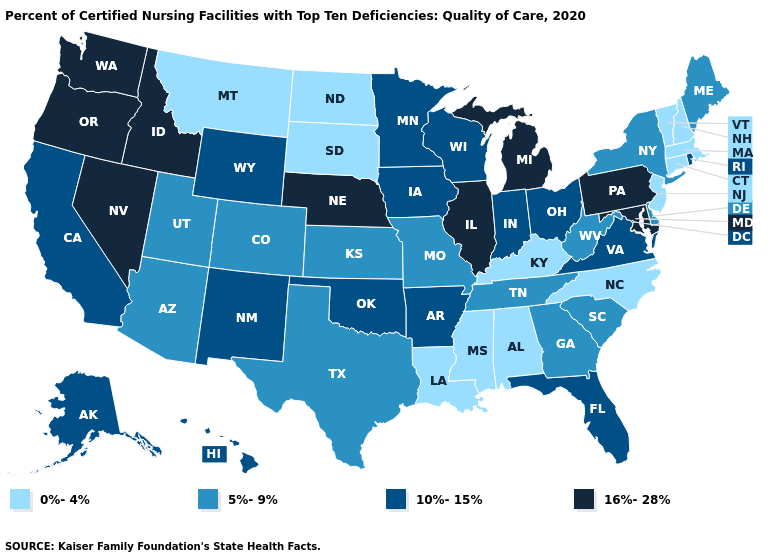Does the map have missing data?
Keep it brief. No. Does Washington have a lower value than Delaware?
Give a very brief answer. No. Does Kansas have the highest value in the MidWest?
Concise answer only. No. What is the lowest value in the South?
Keep it brief. 0%-4%. What is the highest value in the Northeast ?
Give a very brief answer. 16%-28%. What is the value of New York?
Answer briefly. 5%-9%. What is the lowest value in states that border Maryland?
Quick response, please. 5%-9%. Does Kansas have a lower value than Hawaii?
Answer briefly. Yes. What is the highest value in the USA?
Write a very short answer. 16%-28%. Does Nevada have the highest value in the USA?
Write a very short answer. Yes. Does the first symbol in the legend represent the smallest category?
Keep it brief. Yes. What is the highest value in states that border Georgia?
Short answer required. 10%-15%. Does Washington have the same value as Nevada?
Answer briefly. Yes. Among the states that border Mississippi , which have the lowest value?
Be succinct. Alabama, Louisiana. What is the lowest value in states that border Utah?
Short answer required. 5%-9%. 